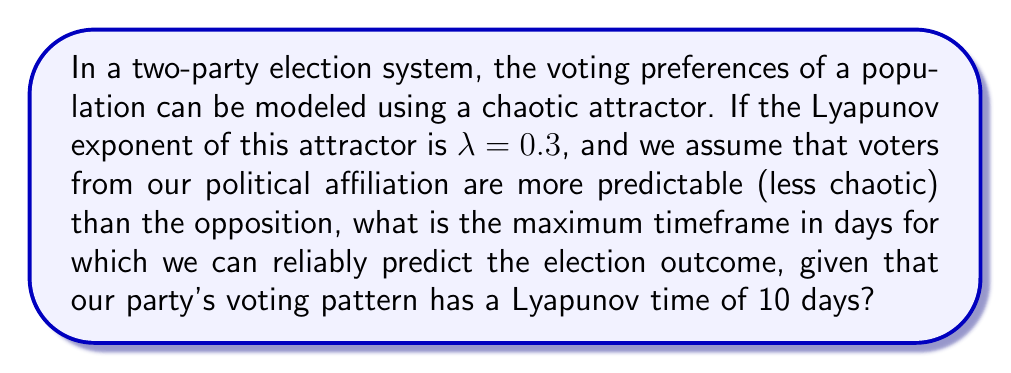Teach me how to tackle this problem. To solve this problem, we need to understand the concept of Lyapunov time and its relation to predictability in chaotic systems. Let's break it down step-by-step:

1) The Lyapunov time $T_{\lambda}$ is defined as the inverse of the Lyapunov exponent $\lambda$:

   $$T_{\lambda} = \frac{1}{\lambda}$$

2) For the given chaotic attractor, $\lambda = 0.3$, so the Lyapunov time is:

   $$T_{\lambda} = \frac{1}{0.3} \approx 3.33 \text{ days}$$

3) This means that for the overall system, predictability decays exponentially with a characteristic time of about 3.33 days.

4) However, we're told that our party's voting pattern has a Lyapunov time of 10 days, which is more predictable than the overall system.

5) In a two-party system, if our party is more predictable, the opposition must be less predictable to maintain the overall Lyapunov exponent.

6) The maximum timeframe for reliable prediction would be determined by our party's Lyapunov time, as it represents the more predictable component.

Therefore, the maximum timeframe for reliable prediction is 10 days, which is our party's Lyapunov time.
Answer: 10 days 